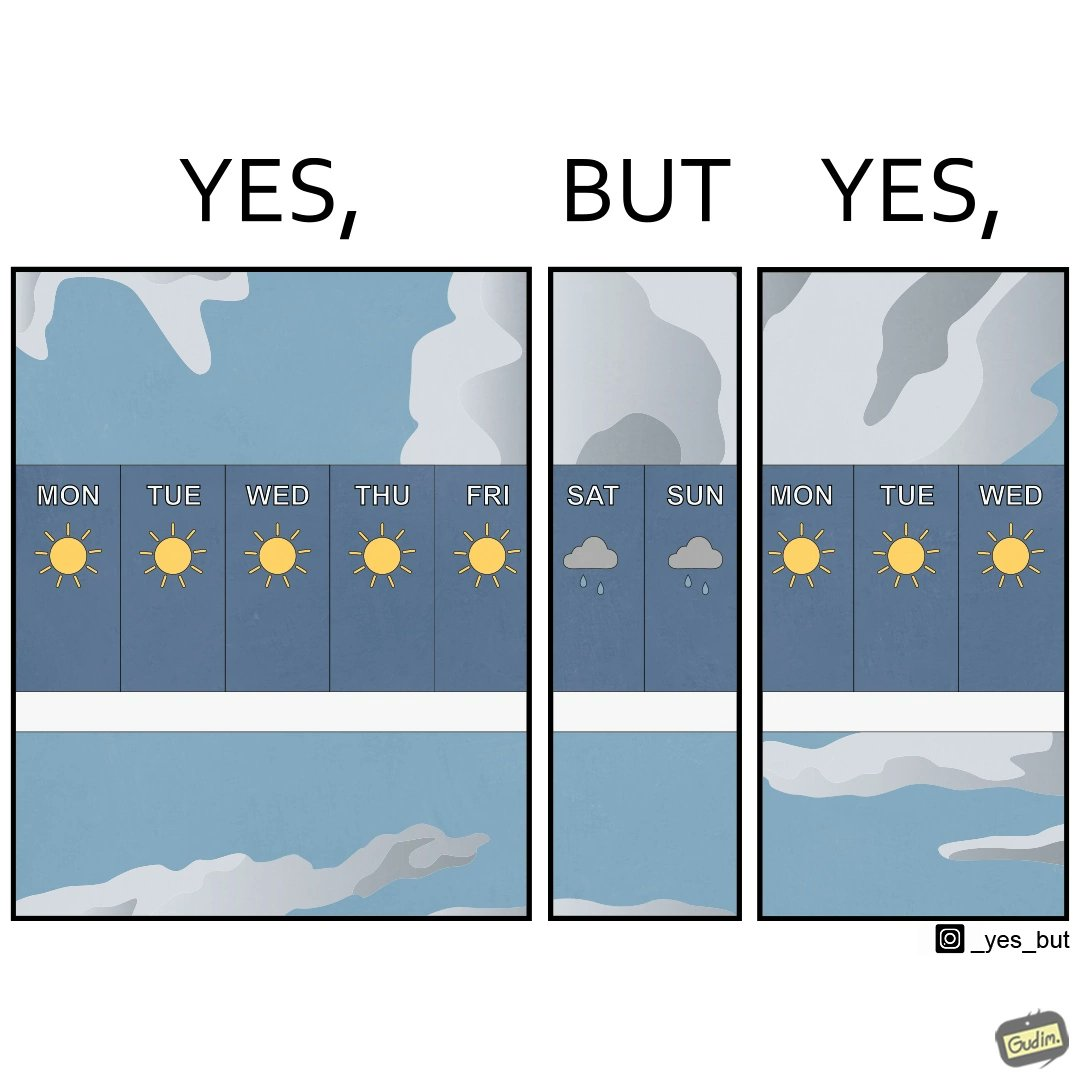Describe the contrast between the left and right parts of this image. In the left part of the image: The weather during weekdays is sunny, shown using an image of the Sun. In the right part of the image: The weather during weekends is rainy, shown using an image of a grey cloud with water drops. 